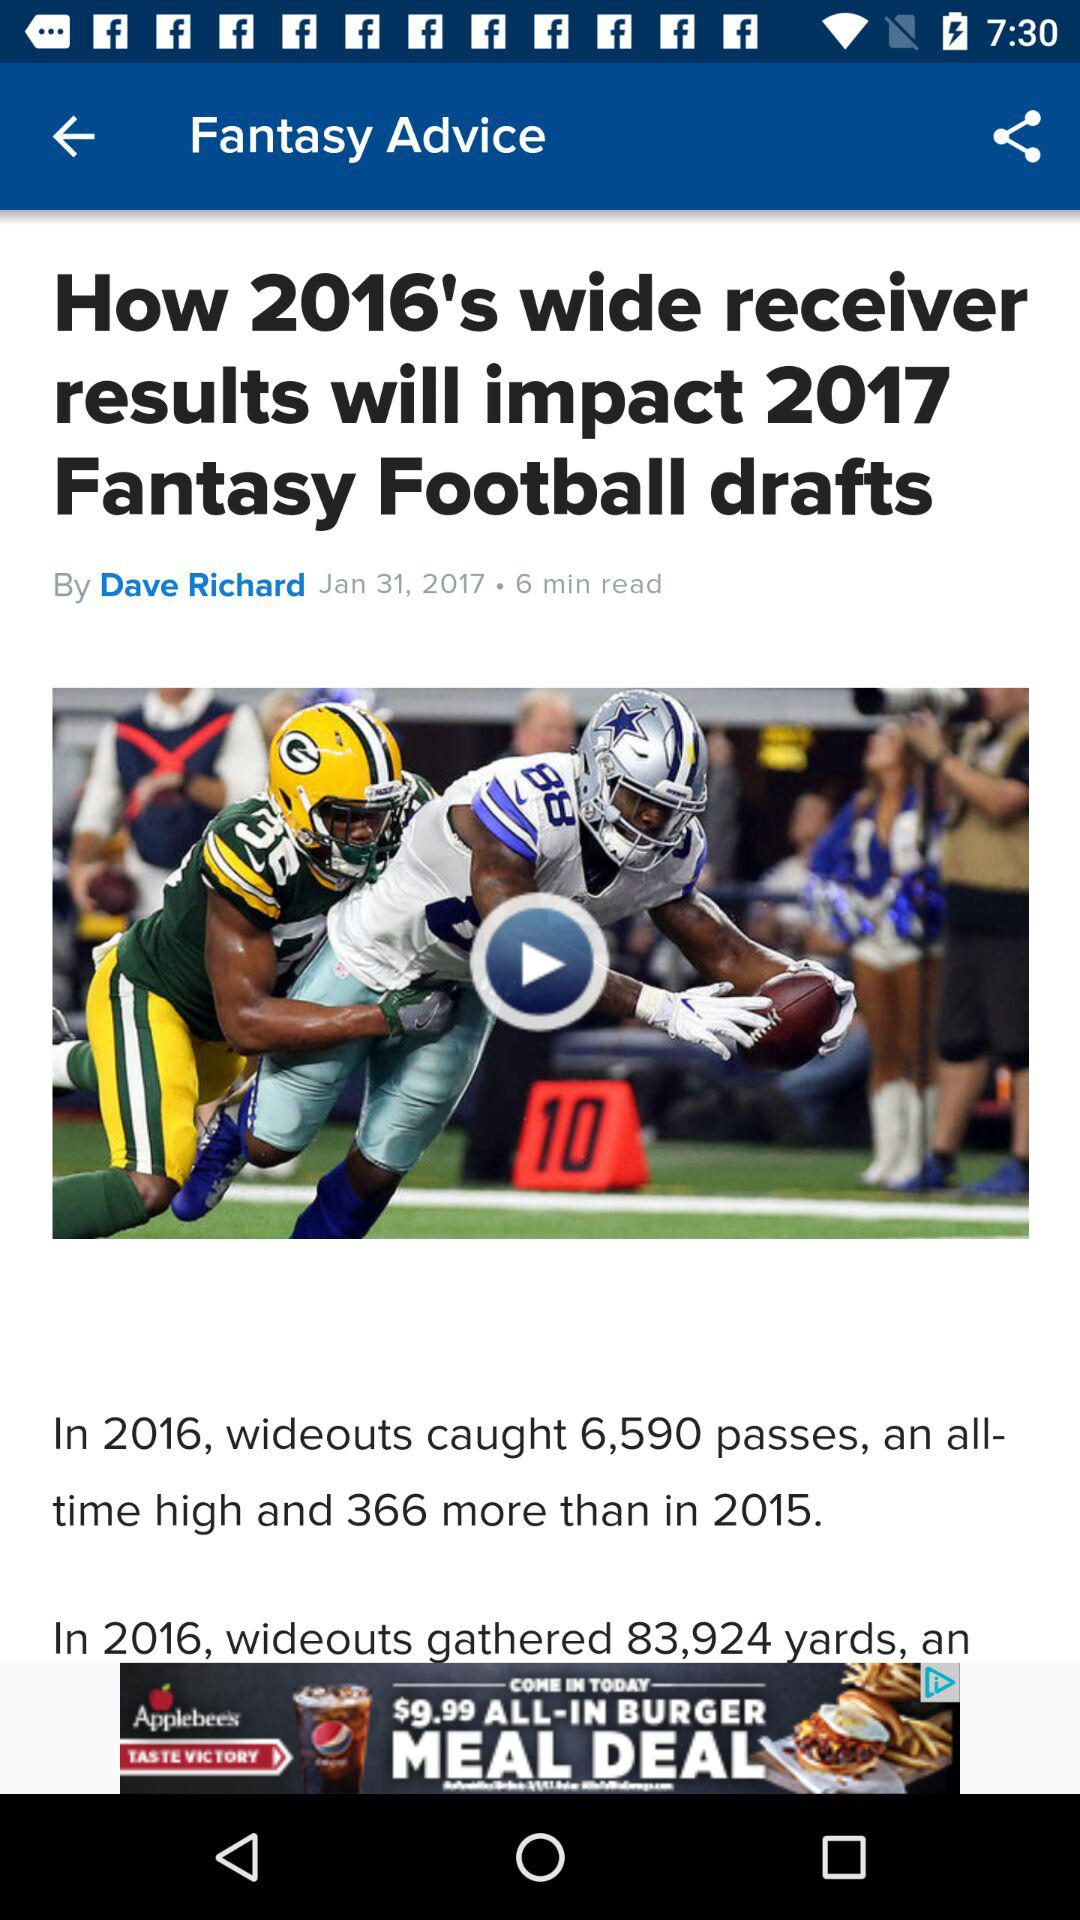What is the name of the author? The name of the author is Dave Richard. 